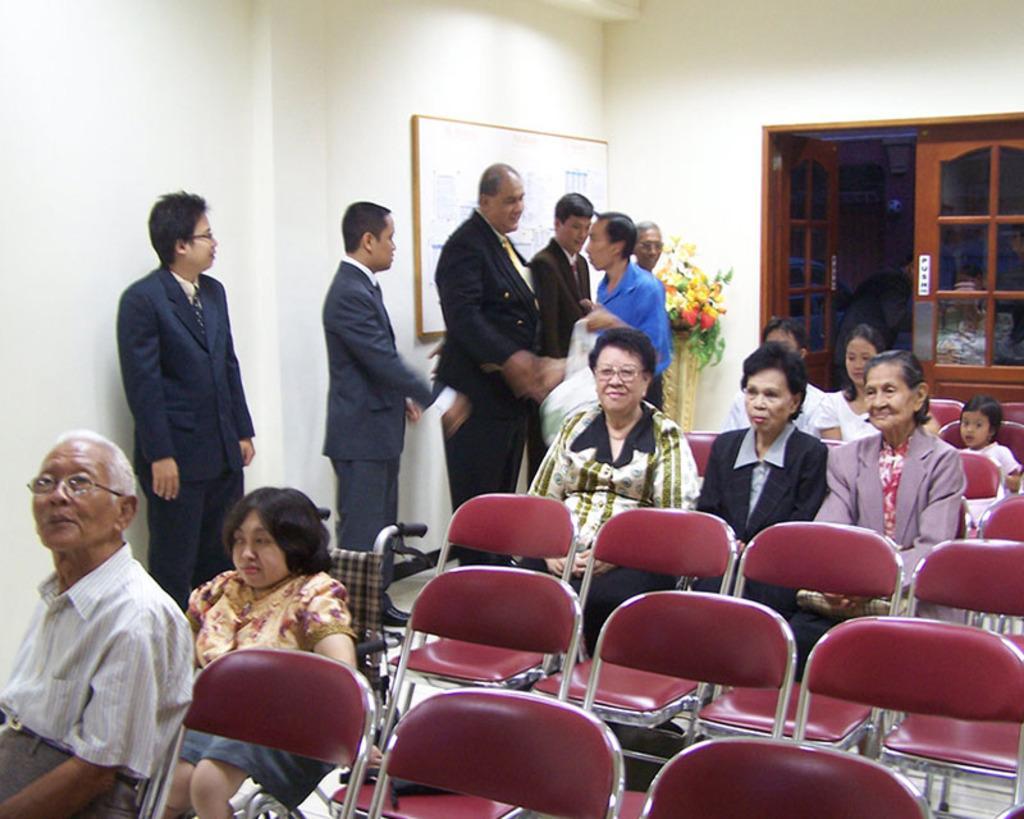In one or two sentences, can you explain what this image depicts? We can see a board over a wall. Here we can see a flower plant. This is a door. We can see persons standing near to the wall. We can see all the persons sitting on chairs. 